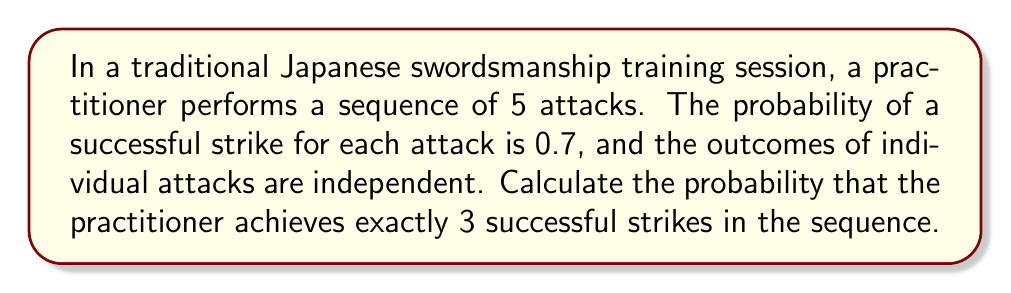Provide a solution to this math problem. To solve this problem, we can use the binomial probability distribution, as we have a fixed number of independent trials (attacks) with two possible outcomes (success or failure) for each trial.

Let's define our variables:
$n = 5$ (number of attacks)
$k = 3$ (number of successful strikes we want)
$p = 0.7$ (probability of success for each strike)
$q = 1 - p = 0.3$ (probability of failure for each strike)

The binomial probability formula is:

$$P(X = k) = \binom{n}{k} p^k q^{n-k}$$

Where $\binom{n}{k}$ is the binomial coefficient, calculated as:

$$\binom{n}{k} = \frac{n!}{k!(n-k)!}$$

Step 1: Calculate the binomial coefficient
$$\binom{5}{3} = \frac{5!}{3!(5-3)!} = \frac{5 \cdot 4}{2 \cdot 1} = 10$$

Step 2: Apply the binomial probability formula
$$P(X = 3) = 10 \cdot (0.7)^3 \cdot (0.3)^{5-3}$$
$$= 10 \cdot (0.7)^3 \cdot (0.3)^2$$
$$= 10 \cdot 0.343 \cdot 0.09$$
$$= 0.3087$$

Therefore, the probability of achieving exactly 3 successful strikes in a sequence of 5 attacks is approximately 0.3087 or 30.87%.
Answer: 0.3087 